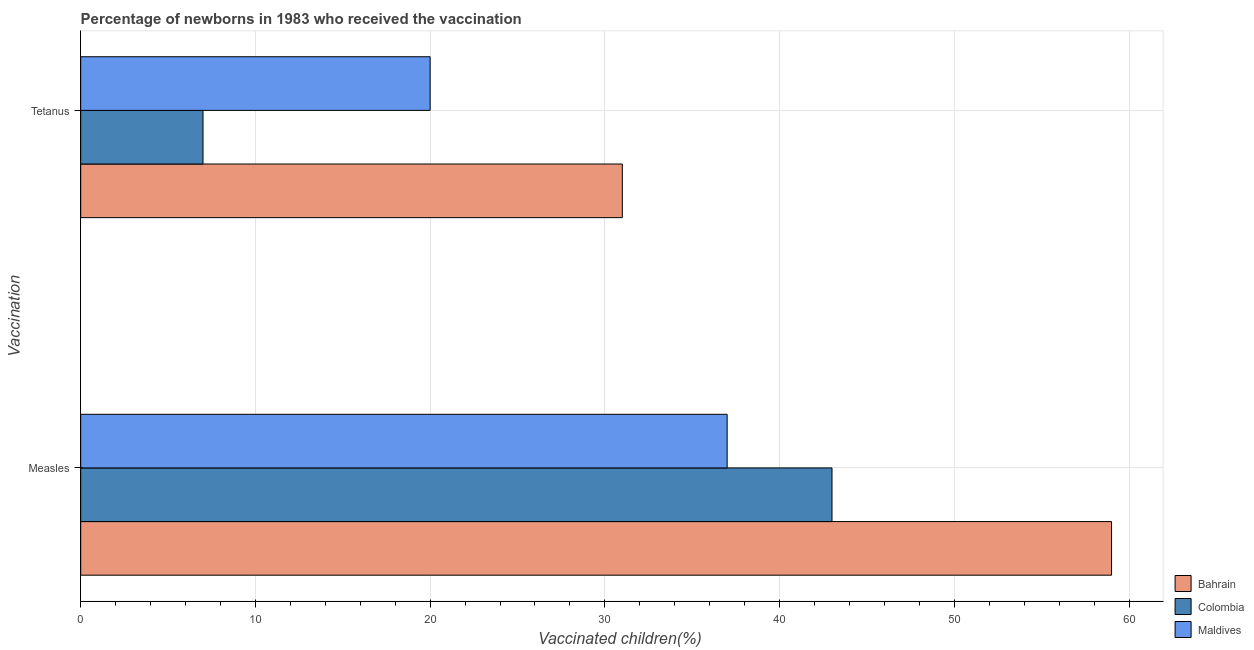How many different coloured bars are there?
Offer a very short reply. 3. How many groups of bars are there?
Your answer should be very brief. 2. Are the number of bars per tick equal to the number of legend labels?
Offer a terse response. Yes. What is the label of the 1st group of bars from the top?
Give a very brief answer. Tetanus. What is the percentage of newborns who received vaccination for tetanus in Maldives?
Provide a short and direct response. 20. Across all countries, what is the maximum percentage of newborns who received vaccination for tetanus?
Offer a terse response. 31. Across all countries, what is the minimum percentage of newborns who received vaccination for tetanus?
Your answer should be compact. 7. In which country was the percentage of newborns who received vaccination for measles maximum?
Give a very brief answer. Bahrain. What is the total percentage of newborns who received vaccination for tetanus in the graph?
Your answer should be compact. 58. What is the difference between the percentage of newborns who received vaccination for measles in Colombia and that in Maldives?
Offer a terse response. 6. What is the difference between the percentage of newborns who received vaccination for tetanus in Bahrain and the percentage of newborns who received vaccination for measles in Colombia?
Make the answer very short. -12. What is the average percentage of newborns who received vaccination for tetanus per country?
Make the answer very short. 19.33. What is the difference between the percentage of newborns who received vaccination for measles and percentage of newborns who received vaccination for tetanus in Bahrain?
Offer a terse response. 28. What is the ratio of the percentage of newborns who received vaccination for measles in Colombia to that in Bahrain?
Provide a succinct answer. 0.73. In how many countries, is the percentage of newborns who received vaccination for tetanus greater than the average percentage of newborns who received vaccination for tetanus taken over all countries?
Keep it short and to the point. 2. What does the 3rd bar from the top in Measles represents?
Give a very brief answer. Bahrain. What does the 1st bar from the bottom in Tetanus represents?
Offer a terse response. Bahrain. Does the graph contain any zero values?
Your response must be concise. No. Does the graph contain grids?
Give a very brief answer. Yes. Where does the legend appear in the graph?
Your answer should be very brief. Bottom right. What is the title of the graph?
Your answer should be compact. Percentage of newborns in 1983 who received the vaccination. Does "Cambodia" appear as one of the legend labels in the graph?
Make the answer very short. No. What is the label or title of the X-axis?
Provide a short and direct response. Vaccinated children(%)
. What is the label or title of the Y-axis?
Offer a terse response. Vaccination. What is the Vaccinated children(%)
 in Bahrain in Measles?
Your answer should be compact. 59. What is the Vaccinated children(%)
 in Maldives in Measles?
Provide a succinct answer. 37. What is the Vaccinated children(%)
 of Colombia in Tetanus?
Your response must be concise. 7. What is the Vaccinated children(%)
 of Maldives in Tetanus?
Make the answer very short. 20. Across all Vaccination, what is the minimum Vaccinated children(%)
 of Bahrain?
Provide a succinct answer. 31. Across all Vaccination, what is the minimum Vaccinated children(%)
 in Colombia?
Provide a succinct answer. 7. What is the total Vaccinated children(%)
 of Bahrain in the graph?
Your answer should be compact. 90. What is the total Vaccinated children(%)
 of Colombia in the graph?
Your answer should be compact. 50. What is the total Vaccinated children(%)
 in Maldives in the graph?
Give a very brief answer. 57. What is the difference between the Vaccinated children(%)
 in Bahrain in Measles and that in Tetanus?
Provide a short and direct response. 28. What is the difference between the Vaccinated children(%)
 of Colombia in Measles and that in Tetanus?
Provide a short and direct response. 36. What is the difference between the Vaccinated children(%)
 in Bahrain in Measles and the Vaccinated children(%)
 in Maldives in Tetanus?
Your answer should be compact. 39. What is the average Vaccinated children(%)
 of Bahrain per Vaccination?
Offer a very short reply. 45. What is the average Vaccinated children(%)
 of Colombia per Vaccination?
Provide a succinct answer. 25. What is the average Vaccinated children(%)
 of Maldives per Vaccination?
Your answer should be compact. 28.5. What is the difference between the Vaccinated children(%)
 in Bahrain and Vaccinated children(%)
 in Colombia in Measles?
Ensure brevity in your answer.  16. What is the difference between the Vaccinated children(%)
 in Bahrain and Vaccinated children(%)
 in Maldives in Measles?
Your answer should be very brief. 22. What is the ratio of the Vaccinated children(%)
 in Bahrain in Measles to that in Tetanus?
Keep it short and to the point. 1.9. What is the ratio of the Vaccinated children(%)
 of Colombia in Measles to that in Tetanus?
Your answer should be compact. 6.14. What is the ratio of the Vaccinated children(%)
 in Maldives in Measles to that in Tetanus?
Offer a terse response. 1.85. What is the difference between the highest and the second highest Vaccinated children(%)
 of Maldives?
Keep it short and to the point. 17. What is the difference between the highest and the lowest Vaccinated children(%)
 of Bahrain?
Make the answer very short. 28. What is the difference between the highest and the lowest Vaccinated children(%)
 in Colombia?
Provide a short and direct response. 36. 